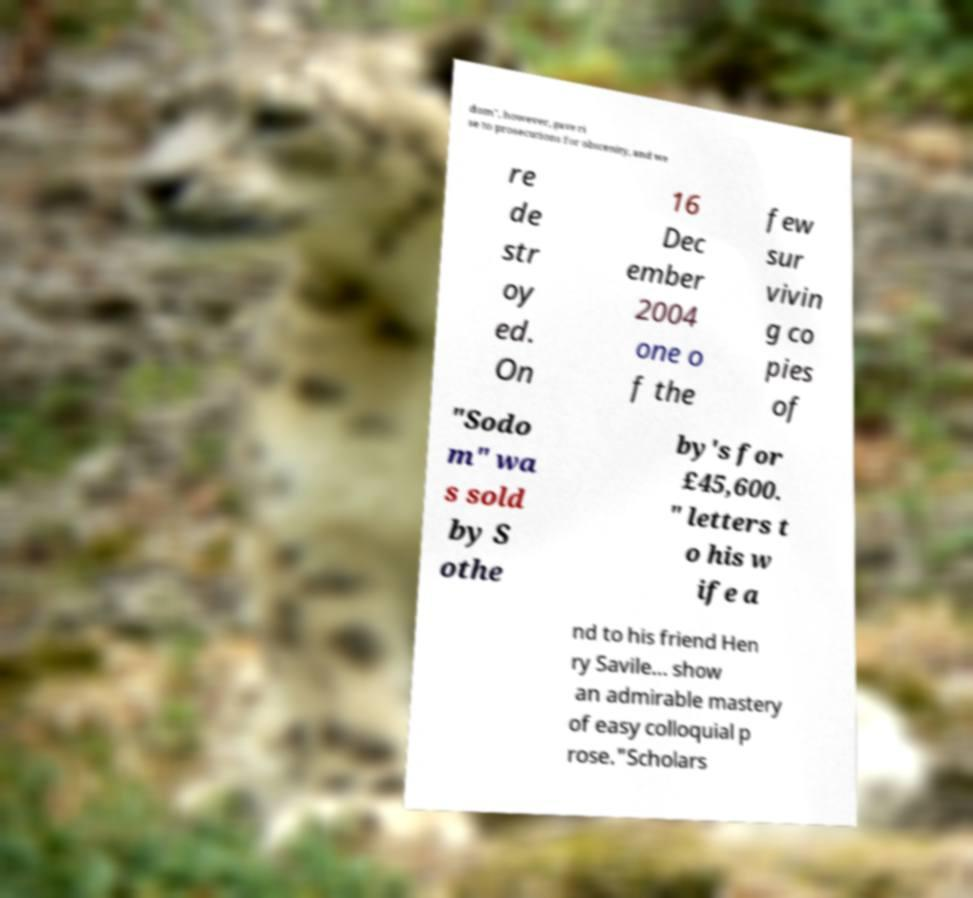Could you assist in decoding the text presented in this image and type it out clearly? dom", however, gave ri se to prosecutions for obscenity, and we re de str oy ed. On 16 Dec ember 2004 one o f the few sur vivin g co pies of "Sodo m" wa s sold by S othe by's for £45,600. " letters t o his w ife a nd to his friend Hen ry Savile… show an admirable mastery of easy colloquial p rose."Scholars 